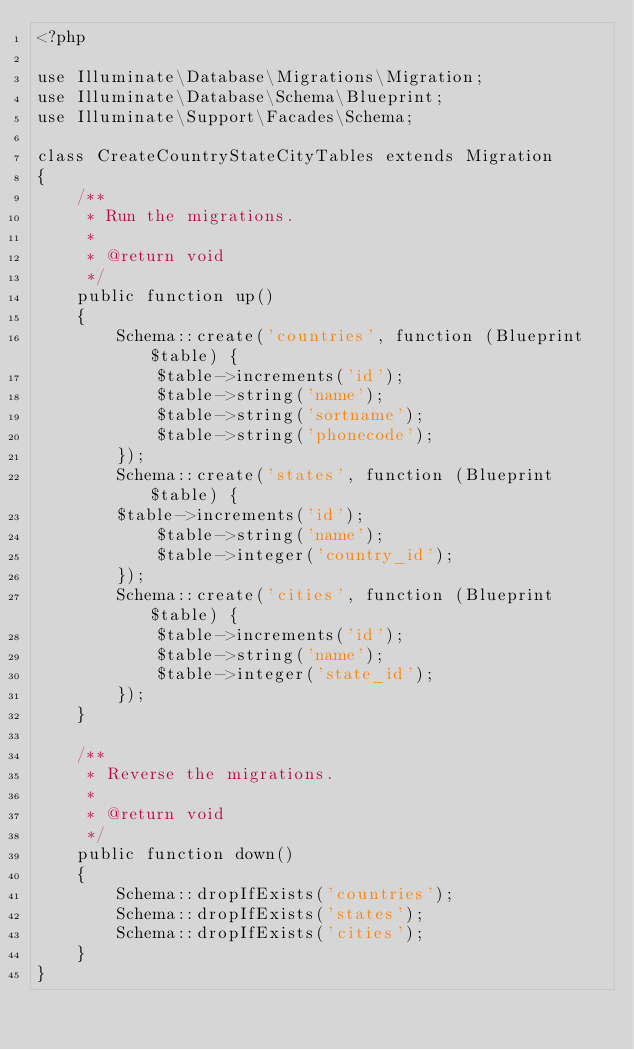Convert code to text. <code><loc_0><loc_0><loc_500><loc_500><_PHP_><?php

use Illuminate\Database\Migrations\Migration;
use Illuminate\Database\Schema\Blueprint;
use Illuminate\Support\Facades\Schema;

class CreateCountryStateCityTables extends Migration
{
    /**
     * Run the migrations.
     *
     * @return void
     */
    public function up()
    {
        Schema::create('countries', function (Blueprint $table) {
            $table->increments('id');
            $table->string('name');
            $table->string('sortname');
            $table->string('phonecode');
        });
        Schema::create('states', function (Blueprint $table) {
        $table->increments('id');
            $table->string('name');
            $table->integer('country_id');
        });
        Schema::create('cities', function (Blueprint $table) {
            $table->increments('id');
            $table->string('name');
            $table->integer('state_id');
        });
    }

    /**
     * Reverse the migrations.
     *
     * @return void
     */
    public function down()
    {
        Schema::dropIfExists('countries');
        Schema::dropIfExists('states');
        Schema::dropIfExists('cities');
    }
}
</code> 